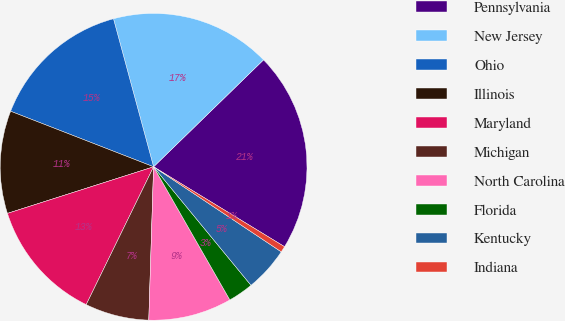Convert chart. <chart><loc_0><loc_0><loc_500><loc_500><pie_chart><fcel>Pennsylvania<fcel>New Jersey<fcel>Ohio<fcel>Illinois<fcel>Maryland<fcel>Michigan<fcel>North Carolina<fcel>Florida<fcel>Kentucky<fcel>Indiana<nl><fcel>21.0%<fcel>16.93%<fcel>14.89%<fcel>10.81%<fcel>12.85%<fcel>6.74%<fcel>8.78%<fcel>2.67%<fcel>4.7%<fcel>0.63%<nl></chart> 